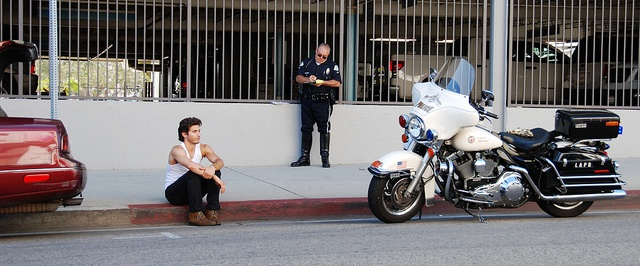Describe the objects in this image and their specific colors. I can see motorcycle in purple, black, lightgray, gray, and darkgray tones, truck in purple, gray, black, and darkgray tones, car in purple, maroon, black, lightpink, and brown tones, people in purple, black, tan, lightgray, and maroon tones, and people in purple, black, gray, and brown tones in this image. 